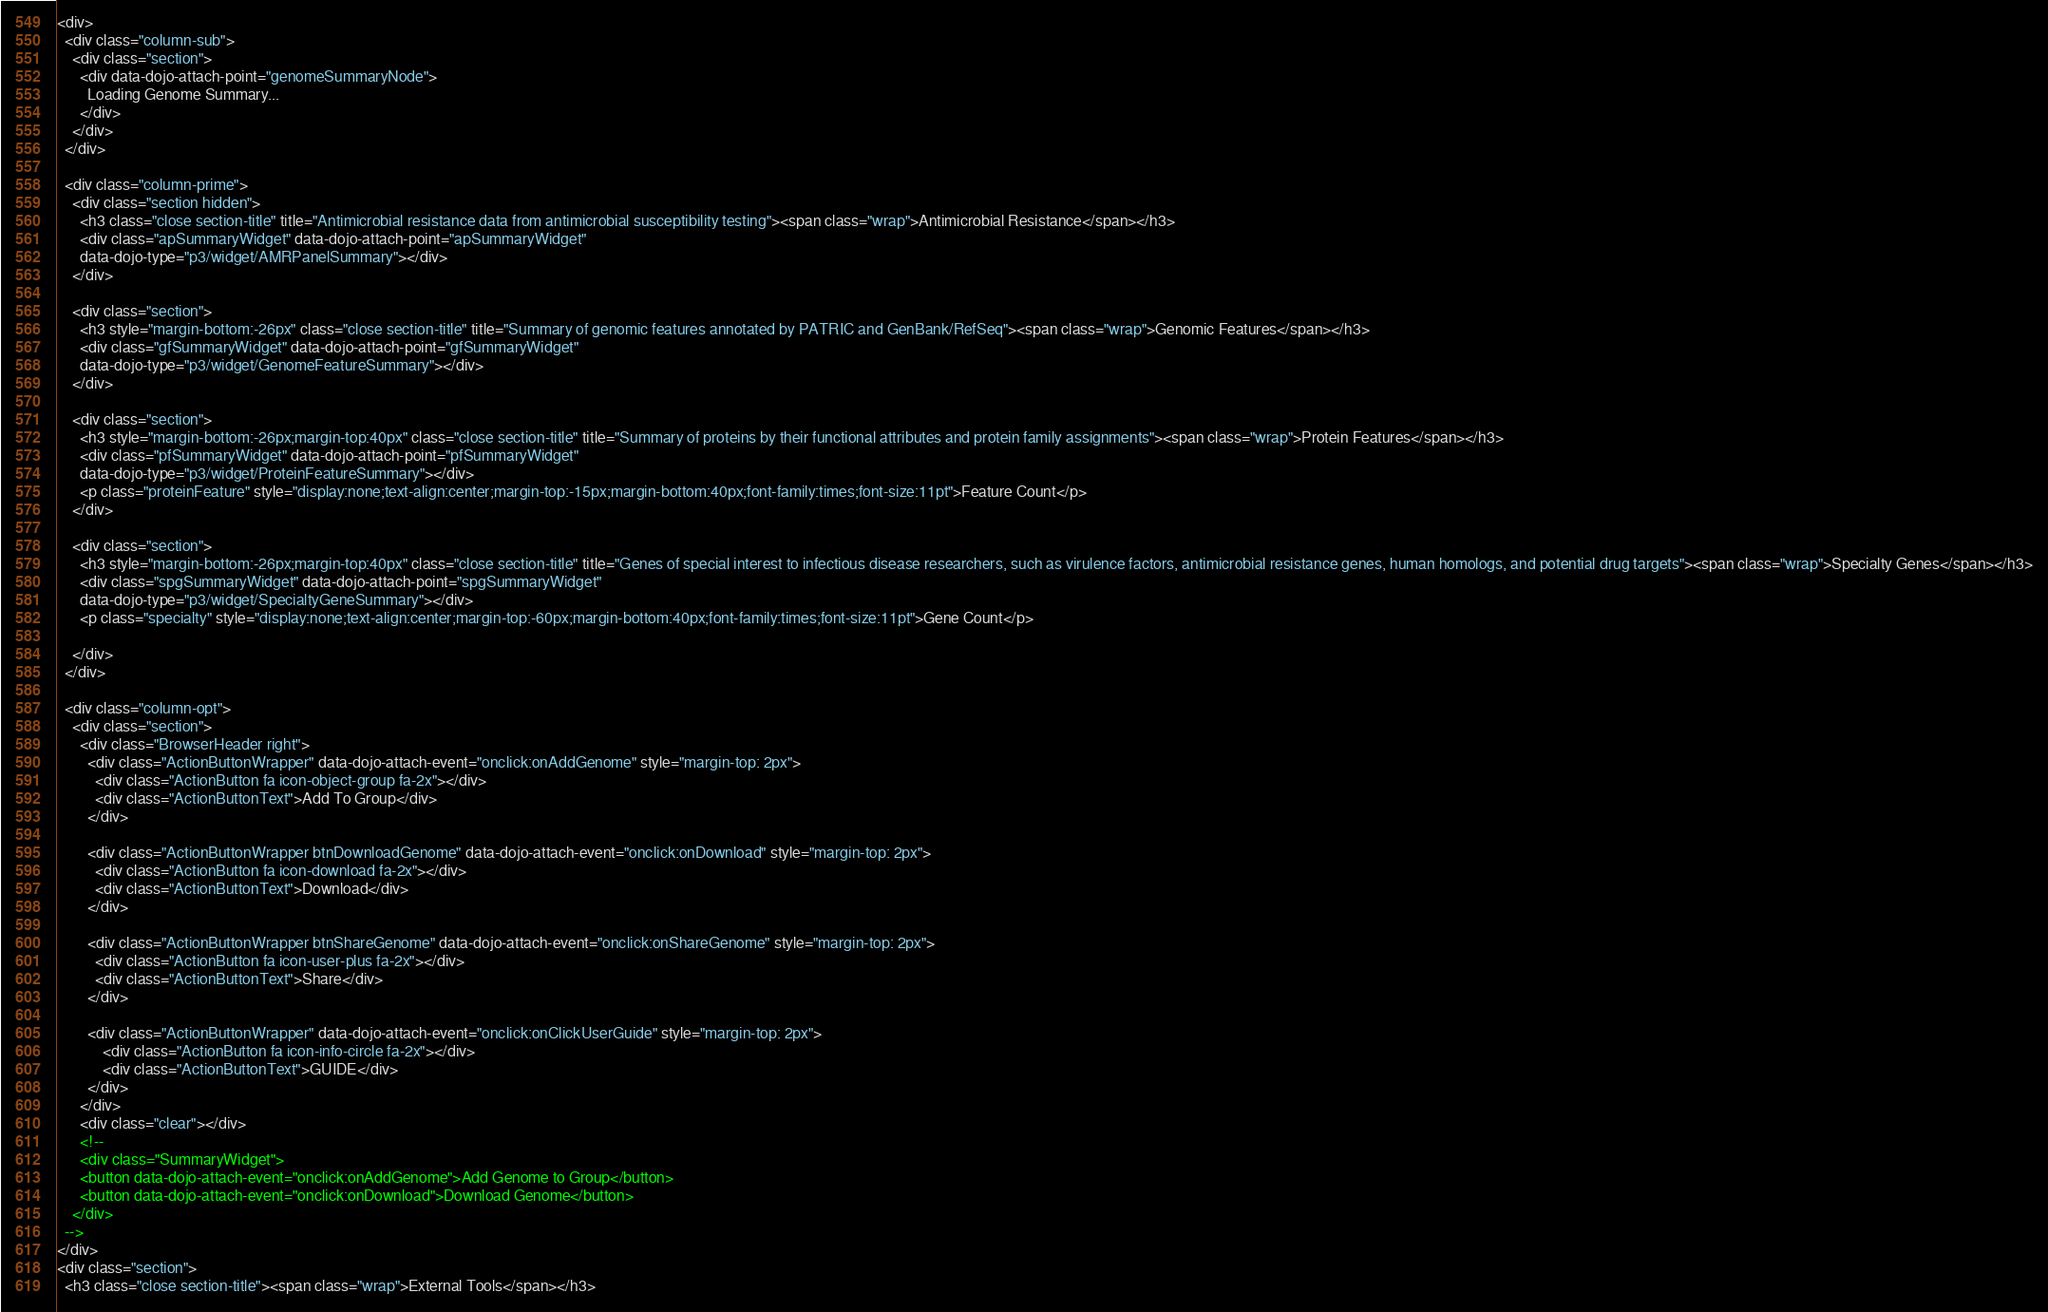<code> <loc_0><loc_0><loc_500><loc_500><_HTML_><div>
  <div class="column-sub">
    <div class="section">
      <div data-dojo-attach-point="genomeSummaryNode">
        Loading Genome Summary...
      </div>
    </div>
  </div>

  <div class="column-prime">
    <div class="section hidden">
      <h3 class="close section-title" title="Antimicrobial resistance data from antimicrobial susceptibility testing"><span class="wrap">Antimicrobial Resistance</span></h3>
      <div class="apSummaryWidget" data-dojo-attach-point="apSummaryWidget"
      data-dojo-type="p3/widget/AMRPanelSummary"></div>
    </div>

    <div class="section">
      <h3 style="margin-bottom:-26px" class="close section-title" title="Summary of genomic features annotated by PATRIC and GenBank/RefSeq"><span class="wrap">Genomic Features</span></h3>
      <div class="gfSummaryWidget" data-dojo-attach-point="gfSummaryWidget"
      data-dojo-type="p3/widget/GenomeFeatureSummary"></div>
    </div>

    <div class="section">
      <h3 style="margin-bottom:-26px;margin-top:40px" class="close section-title" title="Summary of proteins by their functional attributes and protein family assignments"><span class="wrap">Protein Features</span></h3>
      <div class="pfSummaryWidget" data-dojo-attach-point="pfSummaryWidget"
      data-dojo-type="p3/widget/ProteinFeatureSummary"></div>
      <p class="proteinFeature" style="display:none;text-align:center;margin-top:-15px;margin-bottom:40px;font-family:times;font-size:11pt">Feature Count</p>
    </div>

    <div class="section">
      <h3 style="margin-bottom:-26px;margin-top:40px" class="close section-title" title="Genes of special interest to infectious disease researchers, such as virulence factors, antimicrobial resistance genes, human homologs, and potential drug targets"><span class="wrap">Specialty Genes</span></h3>
      <div class="spgSummaryWidget" data-dojo-attach-point="spgSummaryWidget"
      data-dojo-type="p3/widget/SpecialtyGeneSummary"></div>
      <p class="specialty" style="display:none;text-align:center;margin-top:-60px;margin-bottom:40px;font-family:times;font-size:11pt">Gene Count</p>

    </div>
  </div>

  <div class="column-opt">
    <div class="section">
      <div class="BrowserHeader right">
        <div class="ActionButtonWrapper" data-dojo-attach-event="onclick:onAddGenome" style="margin-top: 2px">
          <div class="ActionButton fa icon-object-group fa-2x"></div>
          <div class="ActionButtonText">Add To Group</div>
        </div>

        <div class="ActionButtonWrapper btnDownloadGenome" data-dojo-attach-event="onclick:onDownload" style="margin-top: 2px">
          <div class="ActionButton fa icon-download fa-2x"></div>
          <div class="ActionButtonText">Download</div>
        </div>

        <div class="ActionButtonWrapper btnShareGenome" data-dojo-attach-event="onclick:onShareGenome" style="margin-top: 2px">
          <div class="ActionButton fa icon-user-plus fa-2x"></div>
          <div class="ActionButtonText">Share</div>
        </div>

        <div class="ActionButtonWrapper" data-dojo-attach-event="onclick:onClickUserGuide" style="margin-top: 2px">
            <div class="ActionButton fa icon-info-circle fa-2x"></div>
            <div class="ActionButtonText">GUIDE</div>
        </div>
      </div>
      <div class="clear"></div>
      <!--
      <div class="SummaryWidget">
      <button data-dojo-attach-event="onclick:onAddGenome">Add Genome to Group</button>
      <button data-dojo-attach-event="onclick:onDownload">Download Genome</button>
    </div>
  -->
</div>
<div class="section">
  <h3 class="close section-title"><span class="wrap">External Tools</span></h3></code> 